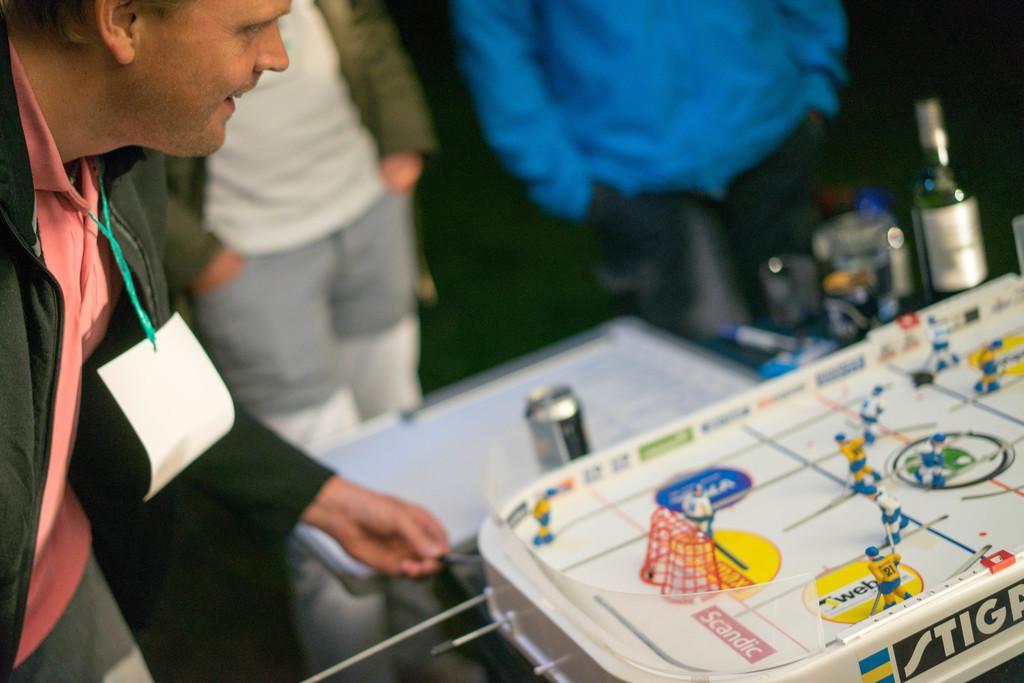Can you describe this image briefly? There is a man standing in front of the table and behind the table there are bottles. 